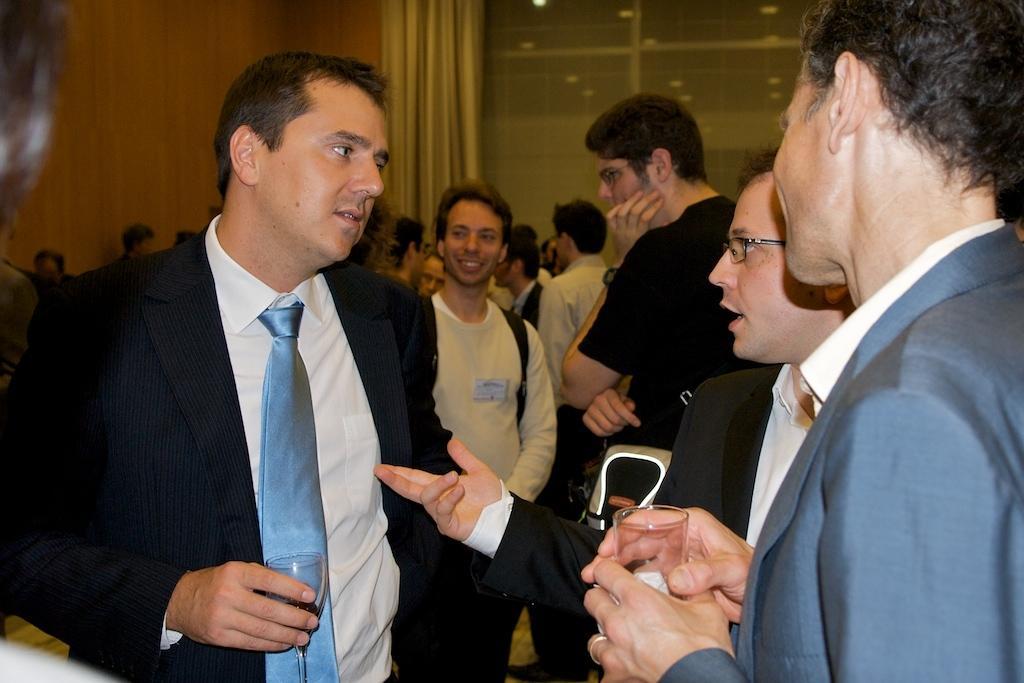How would you summarize this image in a sentence or two? In this image, we can see a group of people are standing. Here a person is talking. Two people are holding glasses. Background we can see wall, curtains and glass object. 